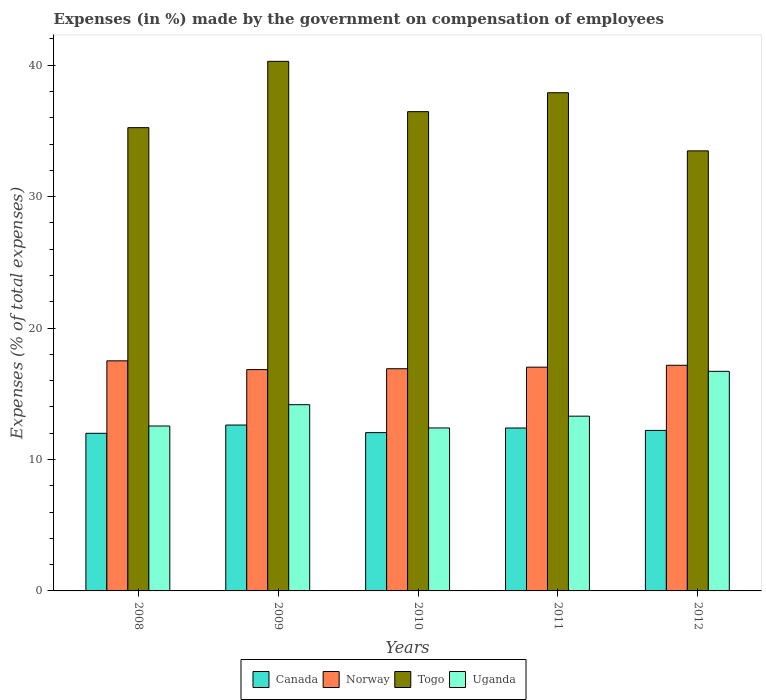How many different coloured bars are there?
Provide a succinct answer. 4. How many groups of bars are there?
Ensure brevity in your answer.  5. Are the number of bars on each tick of the X-axis equal?
Your answer should be compact. Yes. How many bars are there on the 4th tick from the left?
Your answer should be compact. 4. How many bars are there on the 3rd tick from the right?
Make the answer very short. 4. What is the percentage of expenses made by the government on compensation of employees in Uganda in 2011?
Your answer should be compact. 13.3. Across all years, what is the maximum percentage of expenses made by the government on compensation of employees in Uganda?
Give a very brief answer. 16.71. Across all years, what is the minimum percentage of expenses made by the government on compensation of employees in Norway?
Provide a short and direct response. 16.84. In which year was the percentage of expenses made by the government on compensation of employees in Norway maximum?
Ensure brevity in your answer.  2008. In which year was the percentage of expenses made by the government on compensation of employees in Canada minimum?
Keep it short and to the point. 2008. What is the total percentage of expenses made by the government on compensation of employees in Uganda in the graph?
Your answer should be compact. 69.12. What is the difference between the percentage of expenses made by the government on compensation of employees in Uganda in 2009 and that in 2011?
Make the answer very short. 0.87. What is the difference between the percentage of expenses made by the government on compensation of employees in Norway in 2011 and the percentage of expenses made by the government on compensation of employees in Uganda in 2010?
Give a very brief answer. 4.62. What is the average percentage of expenses made by the government on compensation of employees in Togo per year?
Make the answer very short. 36.68. In the year 2012, what is the difference between the percentage of expenses made by the government on compensation of employees in Uganda and percentage of expenses made by the government on compensation of employees in Canada?
Your answer should be very brief. 4.5. In how many years, is the percentage of expenses made by the government on compensation of employees in Norway greater than 22 %?
Keep it short and to the point. 0. What is the ratio of the percentage of expenses made by the government on compensation of employees in Togo in 2008 to that in 2012?
Provide a succinct answer. 1.05. Is the percentage of expenses made by the government on compensation of employees in Norway in 2008 less than that in 2012?
Provide a succinct answer. No. What is the difference between the highest and the second highest percentage of expenses made by the government on compensation of employees in Togo?
Give a very brief answer. 2.39. What is the difference between the highest and the lowest percentage of expenses made by the government on compensation of employees in Uganda?
Offer a terse response. 4.31. In how many years, is the percentage of expenses made by the government on compensation of employees in Uganda greater than the average percentage of expenses made by the government on compensation of employees in Uganda taken over all years?
Your response must be concise. 2. What does the 4th bar from the left in 2010 represents?
Keep it short and to the point. Uganda. What does the 2nd bar from the right in 2010 represents?
Make the answer very short. Togo. Is it the case that in every year, the sum of the percentage of expenses made by the government on compensation of employees in Uganda and percentage of expenses made by the government on compensation of employees in Norway is greater than the percentage of expenses made by the government on compensation of employees in Canada?
Keep it short and to the point. Yes. Are all the bars in the graph horizontal?
Your answer should be compact. No. Are the values on the major ticks of Y-axis written in scientific E-notation?
Your answer should be very brief. No. Does the graph contain any zero values?
Your response must be concise. No. Where does the legend appear in the graph?
Your answer should be very brief. Bottom center. How many legend labels are there?
Make the answer very short. 4. How are the legend labels stacked?
Provide a succinct answer. Horizontal. What is the title of the graph?
Ensure brevity in your answer.  Expenses (in %) made by the government on compensation of employees. What is the label or title of the Y-axis?
Provide a succinct answer. Expenses (% of total expenses). What is the Expenses (% of total expenses) of Canada in 2008?
Ensure brevity in your answer.  11.99. What is the Expenses (% of total expenses) in Norway in 2008?
Make the answer very short. 17.51. What is the Expenses (% of total expenses) of Togo in 2008?
Offer a terse response. 35.25. What is the Expenses (% of total expenses) of Uganda in 2008?
Provide a succinct answer. 12.55. What is the Expenses (% of total expenses) of Canada in 2009?
Make the answer very short. 12.62. What is the Expenses (% of total expenses) of Norway in 2009?
Make the answer very short. 16.84. What is the Expenses (% of total expenses) of Togo in 2009?
Your response must be concise. 40.29. What is the Expenses (% of total expenses) of Uganda in 2009?
Provide a succinct answer. 14.17. What is the Expenses (% of total expenses) in Canada in 2010?
Give a very brief answer. 12.04. What is the Expenses (% of total expenses) in Norway in 2010?
Your answer should be very brief. 16.91. What is the Expenses (% of total expenses) of Togo in 2010?
Offer a very short reply. 36.46. What is the Expenses (% of total expenses) in Uganda in 2010?
Provide a short and direct response. 12.4. What is the Expenses (% of total expenses) of Canada in 2011?
Give a very brief answer. 12.39. What is the Expenses (% of total expenses) in Norway in 2011?
Your response must be concise. 17.02. What is the Expenses (% of total expenses) in Togo in 2011?
Your answer should be very brief. 37.9. What is the Expenses (% of total expenses) of Uganda in 2011?
Offer a very short reply. 13.3. What is the Expenses (% of total expenses) of Canada in 2012?
Make the answer very short. 12.21. What is the Expenses (% of total expenses) in Norway in 2012?
Your answer should be very brief. 17.17. What is the Expenses (% of total expenses) in Togo in 2012?
Keep it short and to the point. 33.48. What is the Expenses (% of total expenses) in Uganda in 2012?
Ensure brevity in your answer.  16.71. Across all years, what is the maximum Expenses (% of total expenses) of Canada?
Make the answer very short. 12.62. Across all years, what is the maximum Expenses (% of total expenses) of Norway?
Your answer should be compact. 17.51. Across all years, what is the maximum Expenses (% of total expenses) in Togo?
Your response must be concise. 40.29. Across all years, what is the maximum Expenses (% of total expenses) in Uganda?
Keep it short and to the point. 16.71. Across all years, what is the minimum Expenses (% of total expenses) of Canada?
Offer a terse response. 11.99. Across all years, what is the minimum Expenses (% of total expenses) of Norway?
Offer a terse response. 16.84. Across all years, what is the minimum Expenses (% of total expenses) in Togo?
Give a very brief answer. 33.48. Across all years, what is the minimum Expenses (% of total expenses) in Uganda?
Keep it short and to the point. 12.4. What is the total Expenses (% of total expenses) in Canada in the graph?
Offer a terse response. 61.26. What is the total Expenses (% of total expenses) in Norway in the graph?
Provide a short and direct response. 85.44. What is the total Expenses (% of total expenses) in Togo in the graph?
Offer a terse response. 183.38. What is the total Expenses (% of total expenses) in Uganda in the graph?
Ensure brevity in your answer.  69.12. What is the difference between the Expenses (% of total expenses) of Canada in 2008 and that in 2009?
Provide a short and direct response. -0.63. What is the difference between the Expenses (% of total expenses) in Norway in 2008 and that in 2009?
Ensure brevity in your answer.  0.67. What is the difference between the Expenses (% of total expenses) of Togo in 2008 and that in 2009?
Offer a very short reply. -5.04. What is the difference between the Expenses (% of total expenses) of Uganda in 2008 and that in 2009?
Your answer should be very brief. -1.62. What is the difference between the Expenses (% of total expenses) of Canada in 2008 and that in 2010?
Your answer should be very brief. -0.05. What is the difference between the Expenses (% of total expenses) of Norway in 2008 and that in 2010?
Give a very brief answer. 0.6. What is the difference between the Expenses (% of total expenses) of Togo in 2008 and that in 2010?
Offer a terse response. -1.22. What is the difference between the Expenses (% of total expenses) of Uganda in 2008 and that in 2010?
Give a very brief answer. 0.15. What is the difference between the Expenses (% of total expenses) of Canada in 2008 and that in 2011?
Your response must be concise. -0.4. What is the difference between the Expenses (% of total expenses) of Norway in 2008 and that in 2011?
Keep it short and to the point. 0.48. What is the difference between the Expenses (% of total expenses) in Togo in 2008 and that in 2011?
Ensure brevity in your answer.  -2.66. What is the difference between the Expenses (% of total expenses) of Uganda in 2008 and that in 2011?
Make the answer very short. -0.75. What is the difference between the Expenses (% of total expenses) of Canada in 2008 and that in 2012?
Keep it short and to the point. -0.22. What is the difference between the Expenses (% of total expenses) in Norway in 2008 and that in 2012?
Ensure brevity in your answer.  0.34. What is the difference between the Expenses (% of total expenses) in Togo in 2008 and that in 2012?
Your answer should be compact. 1.76. What is the difference between the Expenses (% of total expenses) of Uganda in 2008 and that in 2012?
Give a very brief answer. -4.16. What is the difference between the Expenses (% of total expenses) in Canada in 2009 and that in 2010?
Keep it short and to the point. 0.58. What is the difference between the Expenses (% of total expenses) in Norway in 2009 and that in 2010?
Ensure brevity in your answer.  -0.07. What is the difference between the Expenses (% of total expenses) of Togo in 2009 and that in 2010?
Your answer should be compact. 3.83. What is the difference between the Expenses (% of total expenses) of Uganda in 2009 and that in 2010?
Offer a very short reply. 1.77. What is the difference between the Expenses (% of total expenses) of Canada in 2009 and that in 2011?
Ensure brevity in your answer.  0.23. What is the difference between the Expenses (% of total expenses) of Norway in 2009 and that in 2011?
Your answer should be very brief. -0.19. What is the difference between the Expenses (% of total expenses) of Togo in 2009 and that in 2011?
Your answer should be compact. 2.39. What is the difference between the Expenses (% of total expenses) in Uganda in 2009 and that in 2011?
Provide a succinct answer. 0.87. What is the difference between the Expenses (% of total expenses) of Canada in 2009 and that in 2012?
Ensure brevity in your answer.  0.41. What is the difference between the Expenses (% of total expenses) in Norway in 2009 and that in 2012?
Provide a succinct answer. -0.33. What is the difference between the Expenses (% of total expenses) of Togo in 2009 and that in 2012?
Keep it short and to the point. 6.81. What is the difference between the Expenses (% of total expenses) in Uganda in 2009 and that in 2012?
Provide a succinct answer. -2.54. What is the difference between the Expenses (% of total expenses) in Canada in 2010 and that in 2011?
Ensure brevity in your answer.  -0.35. What is the difference between the Expenses (% of total expenses) of Norway in 2010 and that in 2011?
Provide a short and direct response. -0.12. What is the difference between the Expenses (% of total expenses) in Togo in 2010 and that in 2011?
Offer a very short reply. -1.44. What is the difference between the Expenses (% of total expenses) of Uganda in 2010 and that in 2011?
Your response must be concise. -0.9. What is the difference between the Expenses (% of total expenses) of Canada in 2010 and that in 2012?
Ensure brevity in your answer.  -0.17. What is the difference between the Expenses (% of total expenses) in Norway in 2010 and that in 2012?
Give a very brief answer. -0.26. What is the difference between the Expenses (% of total expenses) in Togo in 2010 and that in 2012?
Offer a terse response. 2.98. What is the difference between the Expenses (% of total expenses) of Uganda in 2010 and that in 2012?
Offer a terse response. -4.31. What is the difference between the Expenses (% of total expenses) in Canada in 2011 and that in 2012?
Offer a very short reply. 0.18. What is the difference between the Expenses (% of total expenses) in Norway in 2011 and that in 2012?
Ensure brevity in your answer.  -0.14. What is the difference between the Expenses (% of total expenses) of Togo in 2011 and that in 2012?
Your answer should be compact. 4.42. What is the difference between the Expenses (% of total expenses) in Uganda in 2011 and that in 2012?
Your response must be concise. -3.41. What is the difference between the Expenses (% of total expenses) of Canada in 2008 and the Expenses (% of total expenses) of Norway in 2009?
Give a very brief answer. -4.85. What is the difference between the Expenses (% of total expenses) in Canada in 2008 and the Expenses (% of total expenses) in Togo in 2009?
Give a very brief answer. -28.3. What is the difference between the Expenses (% of total expenses) in Canada in 2008 and the Expenses (% of total expenses) in Uganda in 2009?
Offer a terse response. -2.18. What is the difference between the Expenses (% of total expenses) in Norway in 2008 and the Expenses (% of total expenses) in Togo in 2009?
Your response must be concise. -22.79. What is the difference between the Expenses (% of total expenses) in Norway in 2008 and the Expenses (% of total expenses) in Uganda in 2009?
Your answer should be compact. 3.34. What is the difference between the Expenses (% of total expenses) in Togo in 2008 and the Expenses (% of total expenses) in Uganda in 2009?
Offer a terse response. 21.08. What is the difference between the Expenses (% of total expenses) of Canada in 2008 and the Expenses (% of total expenses) of Norway in 2010?
Ensure brevity in your answer.  -4.91. What is the difference between the Expenses (% of total expenses) of Canada in 2008 and the Expenses (% of total expenses) of Togo in 2010?
Make the answer very short. -24.47. What is the difference between the Expenses (% of total expenses) in Canada in 2008 and the Expenses (% of total expenses) in Uganda in 2010?
Make the answer very short. -0.41. What is the difference between the Expenses (% of total expenses) of Norway in 2008 and the Expenses (% of total expenses) of Togo in 2010?
Keep it short and to the point. -18.96. What is the difference between the Expenses (% of total expenses) in Norway in 2008 and the Expenses (% of total expenses) in Uganda in 2010?
Give a very brief answer. 5.11. What is the difference between the Expenses (% of total expenses) of Togo in 2008 and the Expenses (% of total expenses) of Uganda in 2010?
Offer a terse response. 22.85. What is the difference between the Expenses (% of total expenses) of Canada in 2008 and the Expenses (% of total expenses) of Norway in 2011?
Offer a terse response. -5.03. What is the difference between the Expenses (% of total expenses) of Canada in 2008 and the Expenses (% of total expenses) of Togo in 2011?
Offer a very short reply. -25.91. What is the difference between the Expenses (% of total expenses) of Canada in 2008 and the Expenses (% of total expenses) of Uganda in 2011?
Your response must be concise. -1.3. What is the difference between the Expenses (% of total expenses) in Norway in 2008 and the Expenses (% of total expenses) in Togo in 2011?
Your answer should be compact. -20.4. What is the difference between the Expenses (% of total expenses) of Norway in 2008 and the Expenses (% of total expenses) of Uganda in 2011?
Your answer should be very brief. 4.21. What is the difference between the Expenses (% of total expenses) in Togo in 2008 and the Expenses (% of total expenses) in Uganda in 2011?
Keep it short and to the point. 21.95. What is the difference between the Expenses (% of total expenses) of Canada in 2008 and the Expenses (% of total expenses) of Norway in 2012?
Ensure brevity in your answer.  -5.18. What is the difference between the Expenses (% of total expenses) of Canada in 2008 and the Expenses (% of total expenses) of Togo in 2012?
Make the answer very short. -21.49. What is the difference between the Expenses (% of total expenses) in Canada in 2008 and the Expenses (% of total expenses) in Uganda in 2012?
Provide a short and direct response. -4.71. What is the difference between the Expenses (% of total expenses) in Norway in 2008 and the Expenses (% of total expenses) in Togo in 2012?
Make the answer very short. -15.98. What is the difference between the Expenses (% of total expenses) in Norway in 2008 and the Expenses (% of total expenses) in Uganda in 2012?
Keep it short and to the point. 0.8. What is the difference between the Expenses (% of total expenses) of Togo in 2008 and the Expenses (% of total expenses) of Uganda in 2012?
Provide a succinct answer. 18.54. What is the difference between the Expenses (% of total expenses) in Canada in 2009 and the Expenses (% of total expenses) in Norway in 2010?
Offer a terse response. -4.28. What is the difference between the Expenses (% of total expenses) in Canada in 2009 and the Expenses (% of total expenses) in Togo in 2010?
Offer a terse response. -23.84. What is the difference between the Expenses (% of total expenses) in Canada in 2009 and the Expenses (% of total expenses) in Uganda in 2010?
Provide a succinct answer. 0.22. What is the difference between the Expenses (% of total expenses) of Norway in 2009 and the Expenses (% of total expenses) of Togo in 2010?
Your response must be concise. -19.63. What is the difference between the Expenses (% of total expenses) of Norway in 2009 and the Expenses (% of total expenses) of Uganda in 2010?
Keep it short and to the point. 4.44. What is the difference between the Expenses (% of total expenses) in Togo in 2009 and the Expenses (% of total expenses) in Uganda in 2010?
Your answer should be very brief. 27.89. What is the difference between the Expenses (% of total expenses) of Canada in 2009 and the Expenses (% of total expenses) of Norway in 2011?
Your response must be concise. -4.4. What is the difference between the Expenses (% of total expenses) in Canada in 2009 and the Expenses (% of total expenses) in Togo in 2011?
Your response must be concise. -25.28. What is the difference between the Expenses (% of total expenses) in Canada in 2009 and the Expenses (% of total expenses) in Uganda in 2011?
Make the answer very short. -0.68. What is the difference between the Expenses (% of total expenses) in Norway in 2009 and the Expenses (% of total expenses) in Togo in 2011?
Your response must be concise. -21.07. What is the difference between the Expenses (% of total expenses) of Norway in 2009 and the Expenses (% of total expenses) of Uganda in 2011?
Provide a short and direct response. 3.54. What is the difference between the Expenses (% of total expenses) in Togo in 2009 and the Expenses (% of total expenses) in Uganda in 2011?
Keep it short and to the point. 26.99. What is the difference between the Expenses (% of total expenses) of Canada in 2009 and the Expenses (% of total expenses) of Norway in 2012?
Ensure brevity in your answer.  -4.55. What is the difference between the Expenses (% of total expenses) in Canada in 2009 and the Expenses (% of total expenses) in Togo in 2012?
Your response must be concise. -20.86. What is the difference between the Expenses (% of total expenses) in Canada in 2009 and the Expenses (% of total expenses) in Uganda in 2012?
Give a very brief answer. -4.09. What is the difference between the Expenses (% of total expenses) of Norway in 2009 and the Expenses (% of total expenses) of Togo in 2012?
Your response must be concise. -16.64. What is the difference between the Expenses (% of total expenses) in Norway in 2009 and the Expenses (% of total expenses) in Uganda in 2012?
Provide a short and direct response. 0.13. What is the difference between the Expenses (% of total expenses) in Togo in 2009 and the Expenses (% of total expenses) in Uganda in 2012?
Your response must be concise. 23.58. What is the difference between the Expenses (% of total expenses) of Canada in 2010 and the Expenses (% of total expenses) of Norway in 2011?
Provide a short and direct response. -4.98. What is the difference between the Expenses (% of total expenses) in Canada in 2010 and the Expenses (% of total expenses) in Togo in 2011?
Ensure brevity in your answer.  -25.86. What is the difference between the Expenses (% of total expenses) in Canada in 2010 and the Expenses (% of total expenses) in Uganda in 2011?
Keep it short and to the point. -1.25. What is the difference between the Expenses (% of total expenses) in Norway in 2010 and the Expenses (% of total expenses) in Togo in 2011?
Ensure brevity in your answer.  -21. What is the difference between the Expenses (% of total expenses) in Norway in 2010 and the Expenses (% of total expenses) in Uganda in 2011?
Your answer should be very brief. 3.61. What is the difference between the Expenses (% of total expenses) of Togo in 2010 and the Expenses (% of total expenses) of Uganda in 2011?
Give a very brief answer. 23.17. What is the difference between the Expenses (% of total expenses) of Canada in 2010 and the Expenses (% of total expenses) of Norway in 2012?
Offer a very short reply. -5.12. What is the difference between the Expenses (% of total expenses) of Canada in 2010 and the Expenses (% of total expenses) of Togo in 2012?
Your answer should be compact. -21.44. What is the difference between the Expenses (% of total expenses) in Canada in 2010 and the Expenses (% of total expenses) in Uganda in 2012?
Keep it short and to the point. -4.66. What is the difference between the Expenses (% of total expenses) of Norway in 2010 and the Expenses (% of total expenses) of Togo in 2012?
Offer a terse response. -16.58. What is the difference between the Expenses (% of total expenses) in Norway in 2010 and the Expenses (% of total expenses) in Uganda in 2012?
Make the answer very short. 0.2. What is the difference between the Expenses (% of total expenses) in Togo in 2010 and the Expenses (% of total expenses) in Uganda in 2012?
Offer a very short reply. 19.76. What is the difference between the Expenses (% of total expenses) in Canada in 2011 and the Expenses (% of total expenses) in Norway in 2012?
Provide a short and direct response. -4.77. What is the difference between the Expenses (% of total expenses) in Canada in 2011 and the Expenses (% of total expenses) in Togo in 2012?
Your answer should be very brief. -21.09. What is the difference between the Expenses (% of total expenses) in Canada in 2011 and the Expenses (% of total expenses) in Uganda in 2012?
Give a very brief answer. -4.31. What is the difference between the Expenses (% of total expenses) in Norway in 2011 and the Expenses (% of total expenses) in Togo in 2012?
Your answer should be very brief. -16.46. What is the difference between the Expenses (% of total expenses) of Norway in 2011 and the Expenses (% of total expenses) of Uganda in 2012?
Keep it short and to the point. 0.32. What is the difference between the Expenses (% of total expenses) in Togo in 2011 and the Expenses (% of total expenses) in Uganda in 2012?
Your answer should be compact. 21.2. What is the average Expenses (% of total expenses) of Canada per year?
Provide a short and direct response. 12.25. What is the average Expenses (% of total expenses) in Norway per year?
Ensure brevity in your answer.  17.09. What is the average Expenses (% of total expenses) in Togo per year?
Offer a terse response. 36.68. What is the average Expenses (% of total expenses) of Uganda per year?
Your answer should be compact. 13.82. In the year 2008, what is the difference between the Expenses (% of total expenses) in Canada and Expenses (% of total expenses) in Norway?
Your answer should be compact. -5.51. In the year 2008, what is the difference between the Expenses (% of total expenses) in Canada and Expenses (% of total expenses) in Togo?
Provide a short and direct response. -23.25. In the year 2008, what is the difference between the Expenses (% of total expenses) of Canada and Expenses (% of total expenses) of Uganda?
Your answer should be compact. -0.56. In the year 2008, what is the difference between the Expenses (% of total expenses) of Norway and Expenses (% of total expenses) of Togo?
Offer a terse response. -17.74. In the year 2008, what is the difference between the Expenses (% of total expenses) of Norway and Expenses (% of total expenses) of Uganda?
Provide a short and direct response. 4.96. In the year 2008, what is the difference between the Expenses (% of total expenses) in Togo and Expenses (% of total expenses) in Uganda?
Your answer should be very brief. 22.7. In the year 2009, what is the difference between the Expenses (% of total expenses) of Canada and Expenses (% of total expenses) of Norway?
Ensure brevity in your answer.  -4.22. In the year 2009, what is the difference between the Expenses (% of total expenses) in Canada and Expenses (% of total expenses) in Togo?
Give a very brief answer. -27.67. In the year 2009, what is the difference between the Expenses (% of total expenses) in Canada and Expenses (% of total expenses) in Uganda?
Offer a terse response. -1.55. In the year 2009, what is the difference between the Expenses (% of total expenses) of Norway and Expenses (% of total expenses) of Togo?
Provide a short and direct response. -23.45. In the year 2009, what is the difference between the Expenses (% of total expenses) of Norway and Expenses (% of total expenses) of Uganda?
Provide a succinct answer. 2.67. In the year 2009, what is the difference between the Expenses (% of total expenses) in Togo and Expenses (% of total expenses) in Uganda?
Your response must be concise. 26.12. In the year 2010, what is the difference between the Expenses (% of total expenses) in Canada and Expenses (% of total expenses) in Norway?
Ensure brevity in your answer.  -4.86. In the year 2010, what is the difference between the Expenses (% of total expenses) in Canada and Expenses (% of total expenses) in Togo?
Ensure brevity in your answer.  -24.42. In the year 2010, what is the difference between the Expenses (% of total expenses) of Canada and Expenses (% of total expenses) of Uganda?
Offer a terse response. -0.36. In the year 2010, what is the difference between the Expenses (% of total expenses) of Norway and Expenses (% of total expenses) of Togo?
Provide a succinct answer. -19.56. In the year 2010, what is the difference between the Expenses (% of total expenses) in Norway and Expenses (% of total expenses) in Uganda?
Provide a short and direct response. 4.51. In the year 2010, what is the difference between the Expenses (% of total expenses) in Togo and Expenses (% of total expenses) in Uganda?
Provide a short and direct response. 24.06. In the year 2011, what is the difference between the Expenses (% of total expenses) in Canada and Expenses (% of total expenses) in Norway?
Your answer should be compact. -4.63. In the year 2011, what is the difference between the Expenses (% of total expenses) in Canada and Expenses (% of total expenses) in Togo?
Give a very brief answer. -25.51. In the year 2011, what is the difference between the Expenses (% of total expenses) in Canada and Expenses (% of total expenses) in Uganda?
Keep it short and to the point. -0.9. In the year 2011, what is the difference between the Expenses (% of total expenses) in Norway and Expenses (% of total expenses) in Togo?
Make the answer very short. -20.88. In the year 2011, what is the difference between the Expenses (% of total expenses) of Norway and Expenses (% of total expenses) of Uganda?
Offer a very short reply. 3.73. In the year 2011, what is the difference between the Expenses (% of total expenses) of Togo and Expenses (% of total expenses) of Uganda?
Provide a short and direct response. 24.61. In the year 2012, what is the difference between the Expenses (% of total expenses) of Canada and Expenses (% of total expenses) of Norway?
Your answer should be compact. -4.96. In the year 2012, what is the difference between the Expenses (% of total expenses) of Canada and Expenses (% of total expenses) of Togo?
Keep it short and to the point. -21.27. In the year 2012, what is the difference between the Expenses (% of total expenses) of Canada and Expenses (% of total expenses) of Uganda?
Offer a very short reply. -4.5. In the year 2012, what is the difference between the Expenses (% of total expenses) of Norway and Expenses (% of total expenses) of Togo?
Offer a very short reply. -16.31. In the year 2012, what is the difference between the Expenses (% of total expenses) in Norway and Expenses (% of total expenses) in Uganda?
Keep it short and to the point. 0.46. In the year 2012, what is the difference between the Expenses (% of total expenses) of Togo and Expenses (% of total expenses) of Uganda?
Offer a terse response. 16.77. What is the ratio of the Expenses (% of total expenses) of Canada in 2008 to that in 2009?
Offer a very short reply. 0.95. What is the ratio of the Expenses (% of total expenses) of Norway in 2008 to that in 2009?
Keep it short and to the point. 1.04. What is the ratio of the Expenses (% of total expenses) of Togo in 2008 to that in 2009?
Give a very brief answer. 0.87. What is the ratio of the Expenses (% of total expenses) in Uganda in 2008 to that in 2009?
Give a very brief answer. 0.89. What is the ratio of the Expenses (% of total expenses) in Norway in 2008 to that in 2010?
Ensure brevity in your answer.  1.04. What is the ratio of the Expenses (% of total expenses) in Togo in 2008 to that in 2010?
Give a very brief answer. 0.97. What is the ratio of the Expenses (% of total expenses) of Uganda in 2008 to that in 2010?
Give a very brief answer. 1.01. What is the ratio of the Expenses (% of total expenses) in Canada in 2008 to that in 2011?
Ensure brevity in your answer.  0.97. What is the ratio of the Expenses (% of total expenses) in Norway in 2008 to that in 2011?
Provide a short and direct response. 1.03. What is the ratio of the Expenses (% of total expenses) in Togo in 2008 to that in 2011?
Provide a short and direct response. 0.93. What is the ratio of the Expenses (% of total expenses) of Uganda in 2008 to that in 2011?
Offer a very short reply. 0.94. What is the ratio of the Expenses (% of total expenses) in Canada in 2008 to that in 2012?
Provide a succinct answer. 0.98. What is the ratio of the Expenses (% of total expenses) in Norway in 2008 to that in 2012?
Offer a terse response. 1.02. What is the ratio of the Expenses (% of total expenses) of Togo in 2008 to that in 2012?
Provide a succinct answer. 1.05. What is the ratio of the Expenses (% of total expenses) of Uganda in 2008 to that in 2012?
Make the answer very short. 0.75. What is the ratio of the Expenses (% of total expenses) in Canada in 2009 to that in 2010?
Keep it short and to the point. 1.05. What is the ratio of the Expenses (% of total expenses) in Togo in 2009 to that in 2010?
Your answer should be very brief. 1.1. What is the ratio of the Expenses (% of total expenses) of Uganda in 2009 to that in 2010?
Make the answer very short. 1.14. What is the ratio of the Expenses (% of total expenses) in Canada in 2009 to that in 2011?
Your answer should be very brief. 1.02. What is the ratio of the Expenses (% of total expenses) in Norway in 2009 to that in 2011?
Your answer should be compact. 0.99. What is the ratio of the Expenses (% of total expenses) in Togo in 2009 to that in 2011?
Keep it short and to the point. 1.06. What is the ratio of the Expenses (% of total expenses) of Uganda in 2009 to that in 2011?
Keep it short and to the point. 1.07. What is the ratio of the Expenses (% of total expenses) of Canada in 2009 to that in 2012?
Make the answer very short. 1.03. What is the ratio of the Expenses (% of total expenses) in Norway in 2009 to that in 2012?
Your response must be concise. 0.98. What is the ratio of the Expenses (% of total expenses) of Togo in 2009 to that in 2012?
Make the answer very short. 1.2. What is the ratio of the Expenses (% of total expenses) of Uganda in 2009 to that in 2012?
Your response must be concise. 0.85. What is the ratio of the Expenses (% of total expenses) in Canada in 2010 to that in 2011?
Give a very brief answer. 0.97. What is the ratio of the Expenses (% of total expenses) of Togo in 2010 to that in 2011?
Ensure brevity in your answer.  0.96. What is the ratio of the Expenses (% of total expenses) of Uganda in 2010 to that in 2011?
Ensure brevity in your answer.  0.93. What is the ratio of the Expenses (% of total expenses) of Canada in 2010 to that in 2012?
Your response must be concise. 0.99. What is the ratio of the Expenses (% of total expenses) of Norway in 2010 to that in 2012?
Offer a terse response. 0.98. What is the ratio of the Expenses (% of total expenses) in Togo in 2010 to that in 2012?
Keep it short and to the point. 1.09. What is the ratio of the Expenses (% of total expenses) in Uganda in 2010 to that in 2012?
Keep it short and to the point. 0.74. What is the ratio of the Expenses (% of total expenses) of Canada in 2011 to that in 2012?
Offer a terse response. 1.02. What is the ratio of the Expenses (% of total expenses) in Norway in 2011 to that in 2012?
Your response must be concise. 0.99. What is the ratio of the Expenses (% of total expenses) in Togo in 2011 to that in 2012?
Make the answer very short. 1.13. What is the ratio of the Expenses (% of total expenses) in Uganda in 2011 to that in 2012?
Your response must be concise. 0.8. What is the difference between the highest and the second highest Expenses (% of total expenses) in Canada?
Ensure brevity in your answer.  0.23. What is the difference between the highest and the second highest Expenses (% of total expenses) of Norway?
Offer a very short reply. 0.34. What is the difference between the highest and the second highest Expenses (% of total expenses) in Togo?
Provide a short and direct response. 2.39. What is the difference between the highest and the second highest Expenses (% of total expenses) of Uganda?
Your answer should be very brief. 2.54. What is the difference between the highest and the lowest Expenses (% of total expenses) in Canada?
Provide a succinct answer. 0.63. What is the difference between the highest and the lowest Expenses (% of total expenses) in Norway?
Your response must be concise. 0.67. What is the difference between the highest and the lowest Expenses (% of total expenses) of Togo?
Offer a terse response. 6.81. What is the difference between the highest and the lowest Expenses (% of total expenses) in Uganda?
Offer a very short reply. 4.31. 